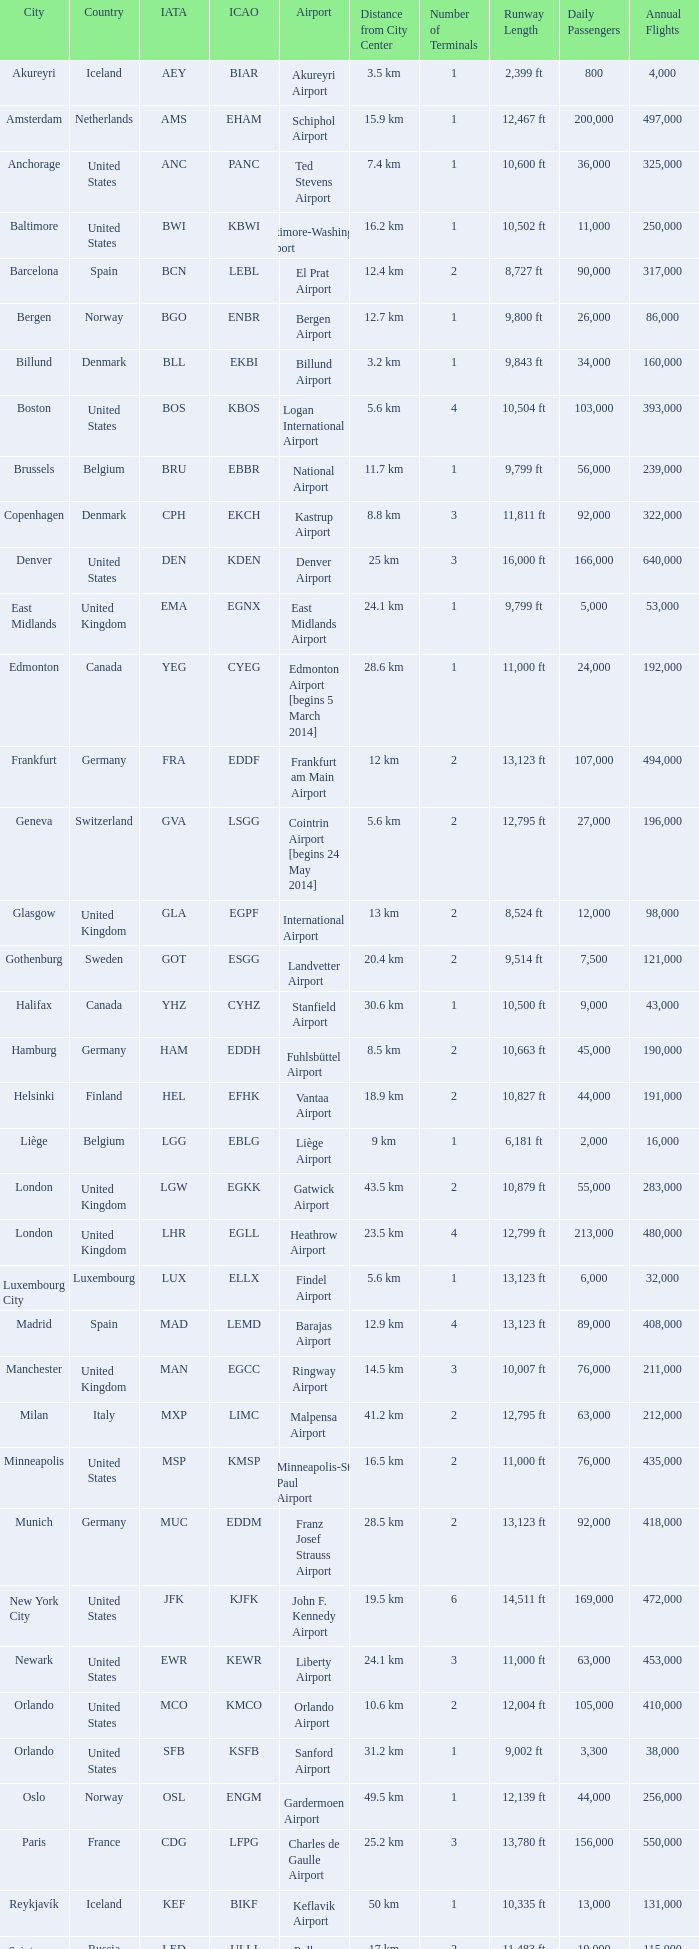Which airport has the icao code ksea? Seattle–Tacoma Airport. 